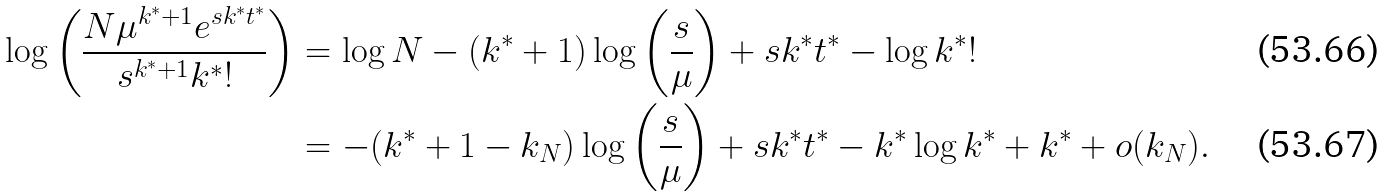Convert formula to latex. <formula><loc_0><loc_0><loc_500><loc_500>\log \left ( \frac { N \mu ^ { k ^ { * } + 1 } e ^ { s k ^ { * } t ^ { * } } } { s ^ { k ^ { * } + 1 } k ^ { * } ! } \right ) & = \log N - ( k ^ { * } + 1 ) \log \left ( \frac { s } { \mu } \right ) + s k ^ { * } t ^ { * } - \log k ^ { * } ! \\ & = - ( k ^ { * } + 1 - k _ { N } ) \log \left ( \frac { s } { \mu } \right ) + s k ^ { * } t ^ { * } - k ^ { * } \log k ^ { * } + k ^ { * } + o ( k _ { N } ) .</formula> 